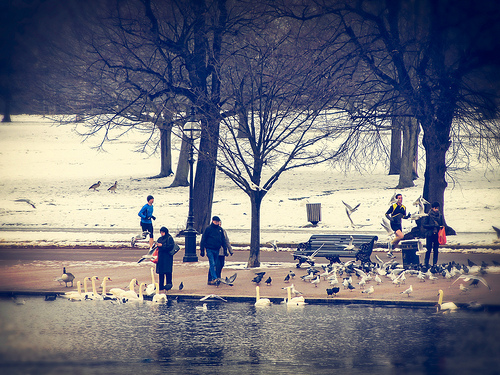<image>
Can you confirm if the snow is behind the duck? Yes. From this viewpoint, the snow is positioned behind the duck, with the duck partially or fully occluding the snow. 